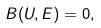<formula> <loc_0><loc_0><loc_500><loc_500>B ( U , E ) = 0 ,</formula> 